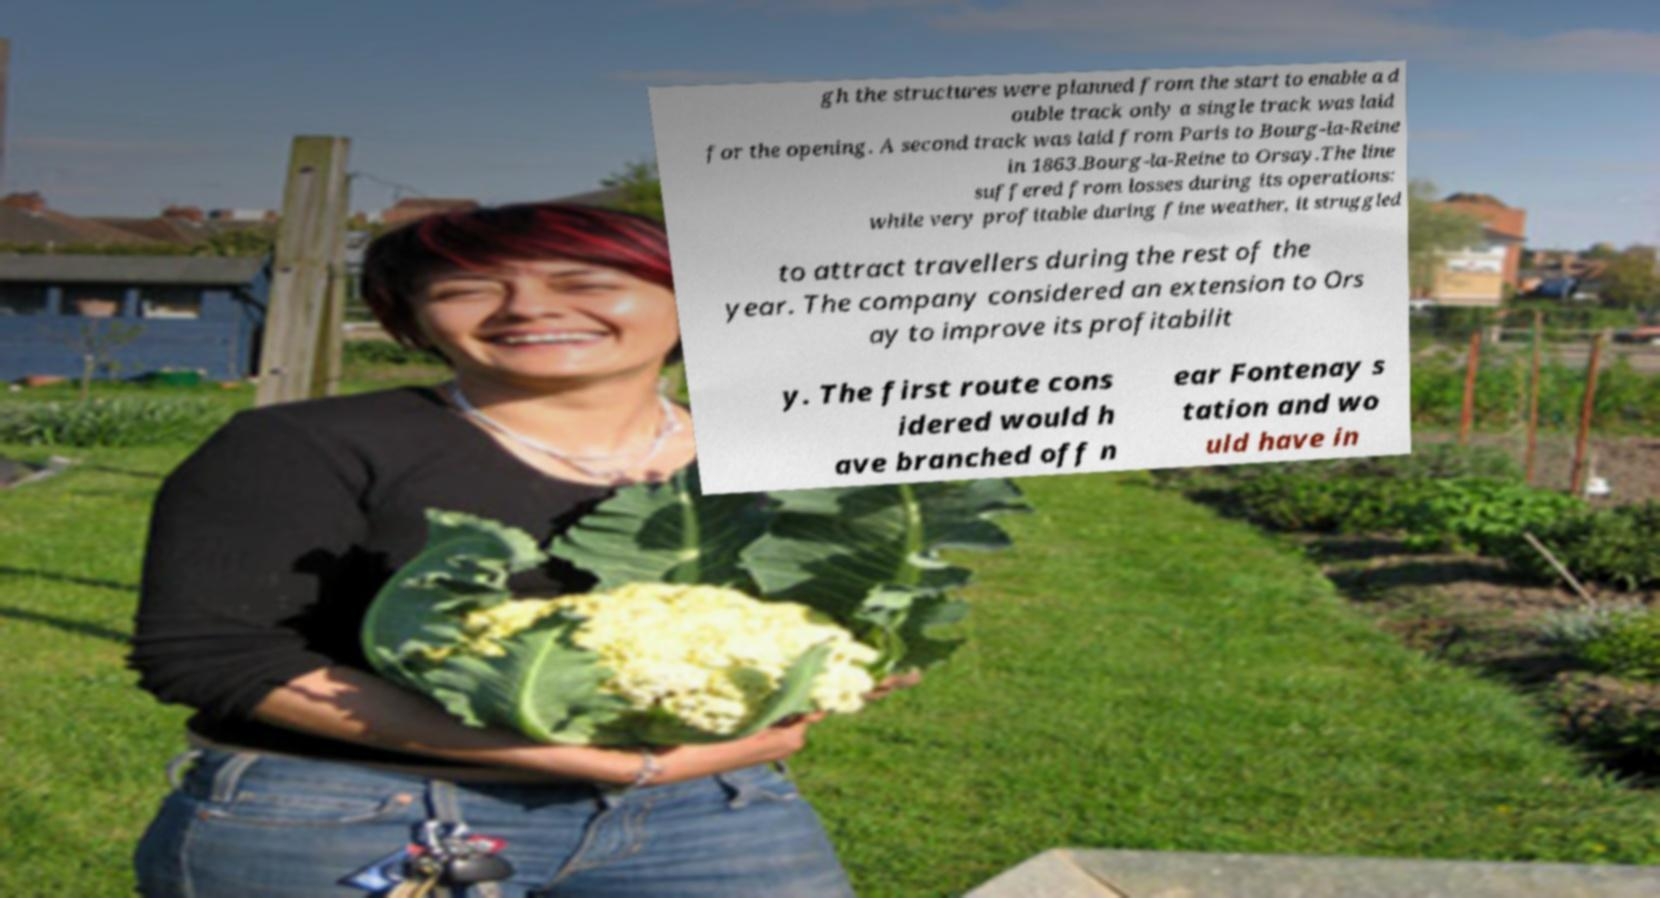Could you extract and type out the text from this image? gh the structures were planned from the start to enable a d ouble track only a single track was laid for the opening. A second track was laid from Paris to Bourg-la-Reine in 1863.Bourg-la-Reine to Orsay.The line suffered from losses during its operations: while very profitable during fine weather, it struggled to attract travellers during the rest of the year. The company considered an extension to Ors ay to improve its profitabilit y. The first route cons idered would h ave branched off n ear Fontenay s tation and wo uld have in 